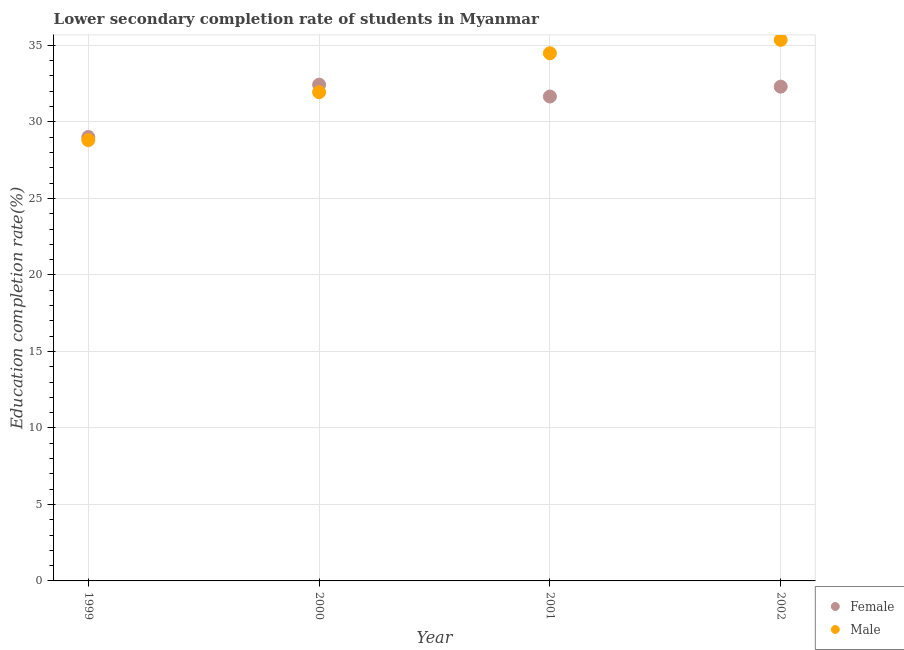How many different coloured dotlines are there?
Provide a short and direct response. 2. Is the number of dotlines equal to the number of legend labels?
Ensure brevity in your answer.  Yes. What is the education completion rate of male students in 2001?
Make the answer very short. 34.49. Across all years, what is the maximum education completion rate of female students?
Give a very brief answer. 32.43. Across all years, what is the minimum education completion rate of male students?
Give a very brief answer. 28.81. What is the total education completion rate of male students in the graph?
Offer a terse response. 130.6. What is the difference between the education completion rate of male students in 2000 and that in 2001?
Make the answer very short. -2.55. What is the difference between the education completion rate of female students in 2002 and the education completion rate of male students in 2000?
Ensure brevity in your answer.  0.36. What is the average education completion rate of male students per year?
Keep it short and to the point. 32.65. In the year 2001, what is the difference between the education completion rate of male students and education completion rate of female students?
Keep it short and to the point. 2.83. What is the ratio of the education completion rate of male students in 1999 to that in 2001?
Keep it short and to the point. 0.84. Is the education completion rate of female students in 1999 less than that in 2001?
Offer a terse response. Yes. What is the difference between the highest and the second highest education completion rate of female students?
Your answer should be compact. 0.13. What is the difference between the highest and the lowest education completion rate of female students?
Offer a very short reply. 3.42. Is the sum of the education completion rate of male students in 2001 and 2002 greater than the maximum education completion rate of female students across all years?
Offer a very short reply. Yes. Is the education completion rate of female students strictly less than the education completion rate of male students over the years?
Offer a very short reply. No. How many dotlines are there?
Your response must be concise. 2. How many years are there in the graph?
Your answer should be very brief. 4. Where does the legend appear in the graph?
Provide a short and direct response. Bottom right. How many legend labels are there?
Offer a terse response. 2. What is the title of the graph?
Keep it short and to the point. Lower secondary completion rate of students in Myanmar. Does "Diesel" appear as one of the legend labels in the graph?
Offer a very short reply. No. What is the label or title of the Y-axis?
Provide a succinct answer. Education completion rate(%). What is the Education completion rate(%) of Female in 1999?
Make the answer very short. 29.01. What is the Education completion rate(%) in Male in 1999?
Offer a terse response. 28.81. What is the Education completion rate(%) of Female in 2000?
Offer a terse response. 32.43. What is the Education completion rate(%) of Male in 2000?
Ensure brevity in your answer.  31.94. What is the Education completion rate(%) in Female in 2001?
Offer a very short reply. 31.66. What is the Education completion rate(%) in Male in 2001?
Your answer should be compact. 34.49. What is the Education completion rate(%) in Female in 2002?
Offer a terse response. 32.3. What is the Education completion rate(%) in Male in 2002?
Ensure brevity in your answer.  35.36. Across all years, what is the maximum Education completion rate(%) of Female?
Your answer should be compact. 32.43. Across all years, what is the maximum Education completion rate(%) in Male?
Offer a terse response. 35.36. Across all years, what is the minimum Education completion rate(%) in Female?
Offer a terse response. 29.01. Across all years, what is the minimum Education completion rate(%) of Male?
Offer a very short reply. 28.81. What is the total Education completion rate(%) in Female in the graph?
Your response must be concise. 125.41. What is the total Education completion rate(%) in Male in the graph?
Your answer should be very brief. 130.6. What is the difference between the Education completion rate(%) in Female in 1999 and that in 2000?
Your answer should be compact. -3.42. What is the difference between the Education completion rate(%) of Male in 1999 and that in 2000?
Your answer should be compact. -3.13. What is the difference between the Education completion rate(%) of Female in 1999 and that in 2001?
Make the answer very short. -2.64. What is the difference between the Education completion rate(%) in Male in 1999 and that in 2001?
Offer a very short reply. -5.68. What is the difference between the Education completion rate(%) in Female in 1999 and that in 2002?
Provide a succinct answer. -3.29. What is the difference between the Education completion rate(%) in Male in 1999 and that in 2002?
Keep it short and to the point. -6.55. What is the difference between the Education completion rate(%) in Female in 2000 and that in 2001?
Provide a short and direct response. 0.78. What is the difference between the Education completion rate(%) in Male in 2000 and that in 2001?
Provide a short and direct response. -2.55. What is the difference between the Education completion rate(%) of Female in 2000 and that in 2002?
Your answer should be very brief. 0.13. What is the difference between the Education completion rate(%) of Male in 2000 and that in 2002?
Ensure brevity in your answer.  -3.42. What is the difference between the Education completion rate(%) of Female in 2001 and that in 2002?
Your response must be concise. -0.65. What is the difference between the Education completion rate(%) of Male in 2001 and that in 2002?
Offer a terse response. -0.87. What is the difference between the Education completion rate(%) of Female in 1999 and the Education completion rate(%) of Male in 2000?
Your response must be concise. -2.93. What is the difference between the Education completion rate(%) in Female in 1999 and the Education completion rate(%) in Male in 2001?
Ensure brevity in your answer.  -5.47. What is the difference between the Education completion rate(%) of Female in 1999 and the Education completion rate(%) of Male in 2002?
Offer a very short reply. -6.35. What is the difference between the Education completion rate(%) in Female in 2000 and the Education completion rate(%) in Male in 2001?
Provide a short and direct response. -2.05. What is the difference between the Education completion rate(%) of Female in 2000 and the Education completion rate(%) of Male in 2002?
Offer a very short reply. -2.93. What is the difference between the Education completion rate(%) of Female in 2001 and the Education completion rate(%) of Male in 2002?
Provide a succinct answer. -3.7. What is the average Education completion rate(%) in Female per year?
Provide a succinct answer. 31.35. What is the average Education completion rate(%) in Male per year?
Offer a terse response. 32.65. In the year 1999, what is the difference between the Education completion rate(%) in Female and Education completion rate(%) in Male?
Offer a terse response. 0.2. In the year 2000, what is the difference between the Education completion rate(%) of Female and Education completion rate(%) of Male?
Offer a terse response. 0.49. In the year 2001, what is the difference between the Education completion rate(%) of Female and Education completion rate(%) of Male?
Provide a short and direct response. -2.83. In the year 2002, what is the difference between the Education completion rate(%) of Female and Education completion rate(%) of Male?
Offer a very short reply. -3.06. What is the ratio of the Education completion rate(%) of Female in 1999 to that in 2000?
Keep it short and to the point. 0.89. What is the ratio of the Education completion rate(%) of Male in 1999 to that in 2000?
Give a very brief answer. 0.9. What is the ratio of the Education completion rate(%) of Female in 1999 to that in 2001?
Provide a succinct answer. 0.92. What is the ratio of the Education completion rate(%) in Male in 1999 to that in 2001?
Provide a short and direct response. 0.84. What is the ratio of the Education completion rate(%) of Female in 1999 to that in 2002?
Keep it short and to the point. 0.9. What is the ratio of the Education completion rate(%) in Male in 1999 to that in 2002?
Ensure brevity in your answer.  0.81. What is the ratio of the Education completion rate(%) of Female in 2000 to that in 2001?
Keep it short and to the point. 1.02. What is the ratio of the Education completion rate(%) in Male in 2000 to that in 2001?
Offer a terse response. 0.93. What is the ratio of the Education completion rate(%) of Female in 2000 to that in 2002?
Provide a short and direct response. 1. What is the ratio of the Education completion rate(%) of Male in 2000 to that in 2002?
Your answer should be very brief. 0.9. What is the ratio of the Education completion rate(%) in Male in 2001 to that in 2002?
Offer a very short reply. 0.98. What is the difference between the highest and the second highest Education completion rate(%) in Female?
Your answer should be very brief. 0.13. What is the difference between the highest and the second highest Education completion rate(%) of Male?
Your answer should be very brief. 0.87. What is the difference between the highest and the lowest Education completion rate(%) in Female?
Provide a short and direct response. 3.42. What is the difference between the highest and the lowest Education completion rate(%) of Male?
Give a very brief answer. 6.55. 